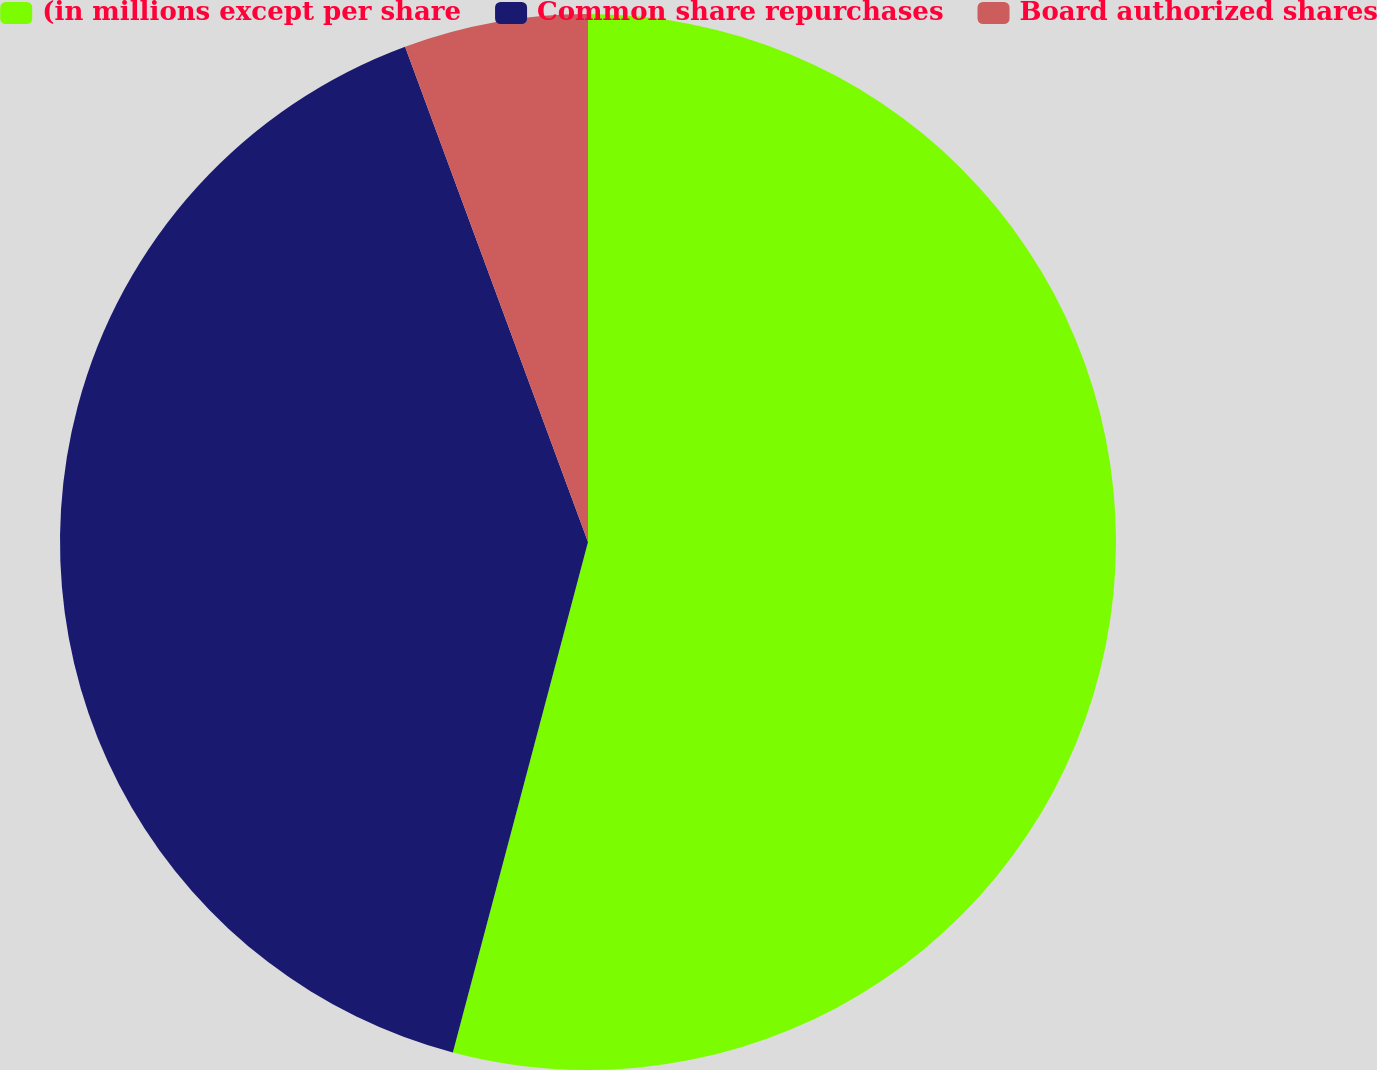Convert chart. <chart><loc_0><loc_0><loc_500><loc_500><pie_chart><fcel>(in millions except per share<fcel>Common share repurchases<fcel>Board authorized shares<nl><fcel>54.12%<fcel>40.25%<fcel>5.63%<nl></chart> 